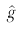<formula> <loc_0><loc_0><loc_500><loc_500>\hat { g }</formula> 